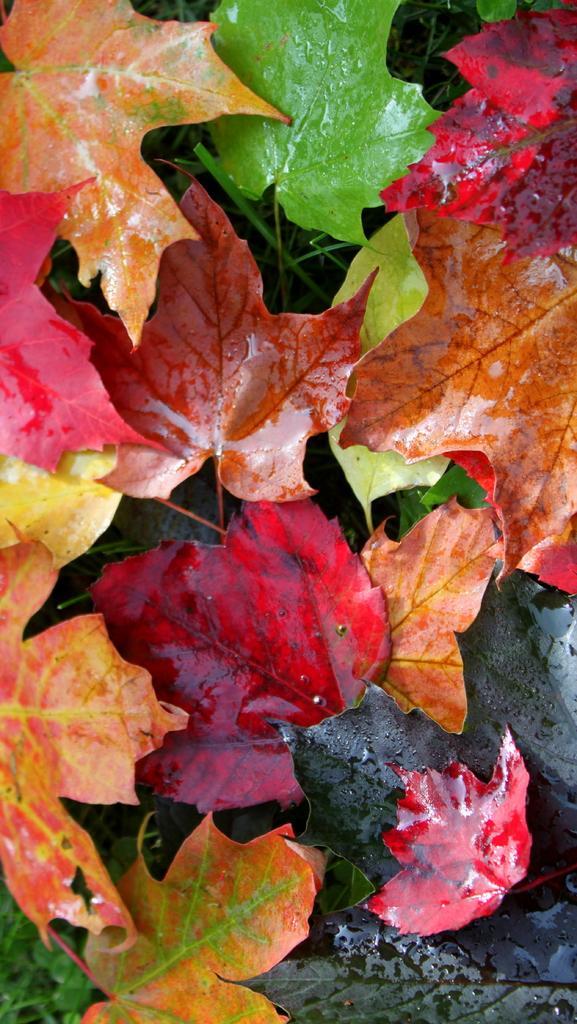Can you describe this image briefly? This image consists of many leaves in different color. At the bottom, there is grass. It looks like a zoomed-in image. 